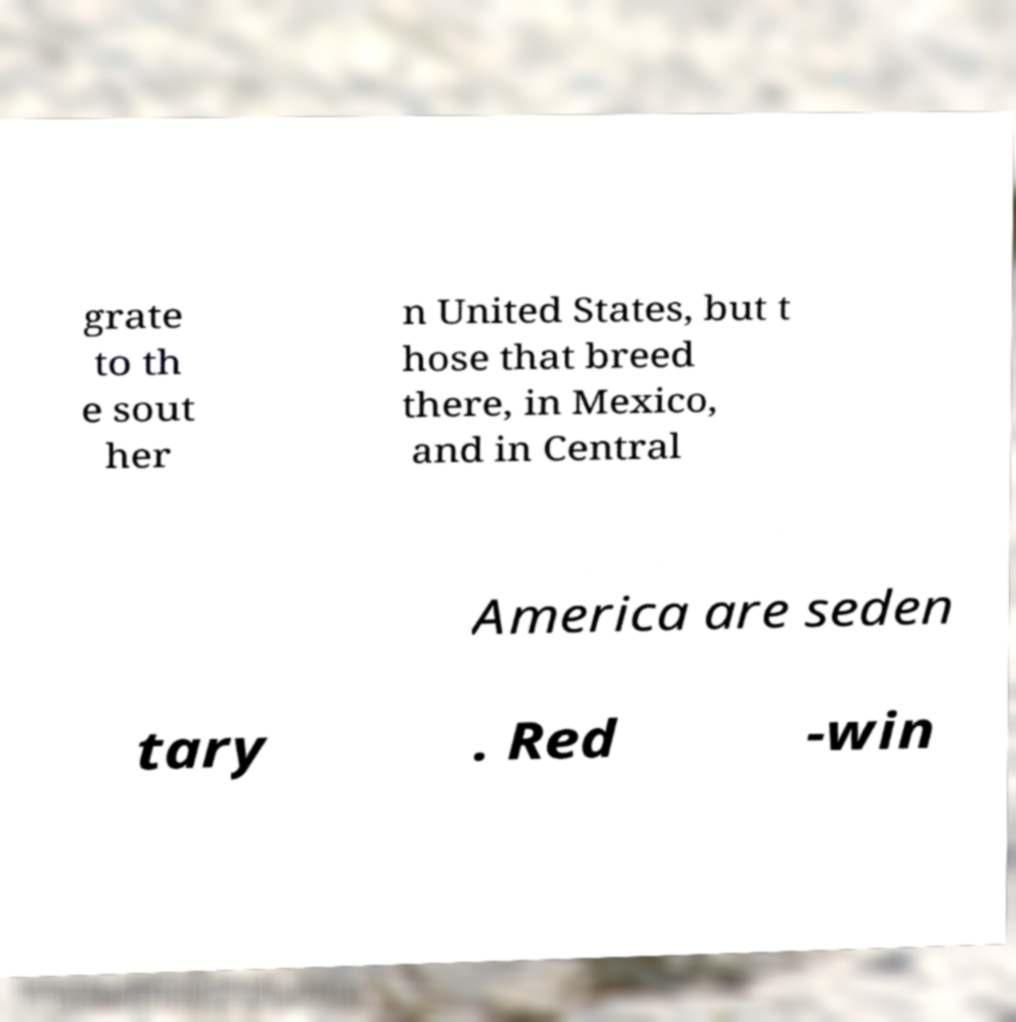Please identify and transcribe the text found in this image. grate to th e sout her n United States, but t hose that breed there, in Mexico, and in Central America are seden tary . Red -win 